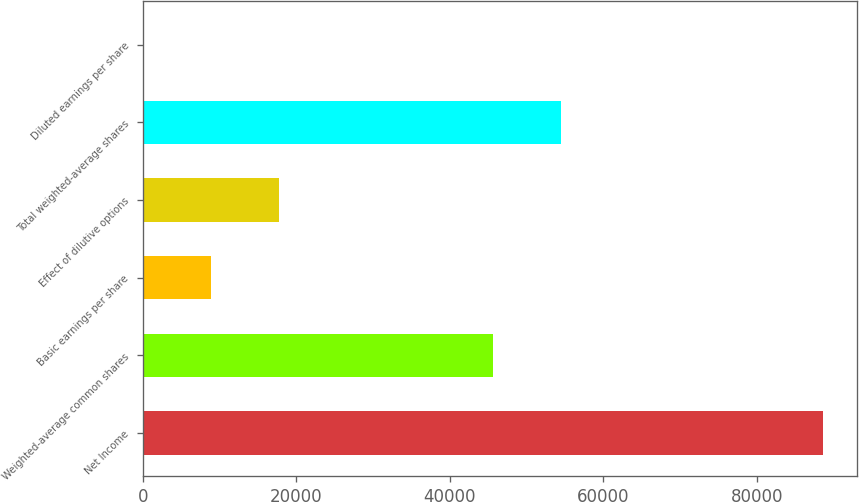Convert chart. <chart><loc_0><loc_0><loc_500><loc_500><bar_chart><fcel>Net Income<fcel>Weighted-average common shares<fcel>Basic earnings per share<fcel>Effect of dilutive options<fcel>Total weighted-average shares<fcel>Diluted earnings per share<nl><fcel>88645<fcel>45630<fcel>8866.15<fcel>17730.5<fcel>54494.3<fcel>1.83<nl></chart> 